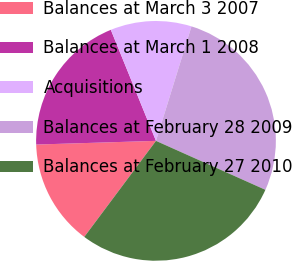<chart> <loc_0><loc_0><loc_500><loc_500><pie_chart><fcel>Balances at March 3 2007<fcel>Balances at March 1 2008<fcel>Acquisitions<fcel>Balances at February 28 2009<fcel>Balances at February 27 2010<nl><fcel>14.3%<fcel>19.34%<fcel>10.93%<fcel>26.91%<fcel>28.51%<nl></chart> 